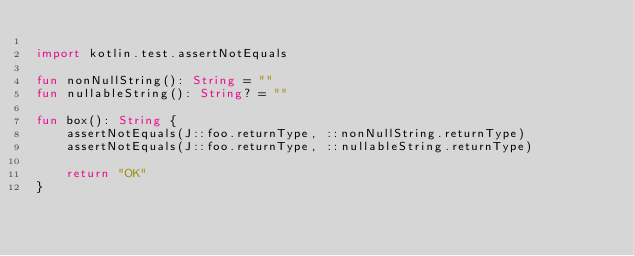Convert code to text. <code><loc_0><loc_0><loc_500><loc_500><_Kotlin_>
import kotlin.test.assertNotEquals

fun nonNullString(): String = ""
fun nullableString(): String? = ""

fun box(): String {
    assertNotEquals(J::foo.returnType, ::nonNullString.returnType)
    assertNotEquals(J::foo.returnType, ::nullableString.returnType)

    return "OK"
}
</code> 